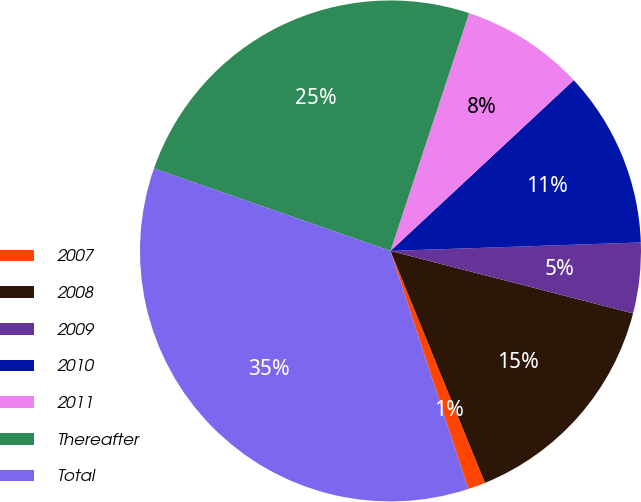<chart> <loc_0><loc_0><loc_500><loc_500><pie_chart><fcel>2007<fcel>2008<fcel>2009<fcel>2010<fcel>2011<fcel>Thereafter<fcel>Total<nl><fcel>1.13%<fcel>14.83%<fcel>4.55%<fcel>11.4%<fcel>7.98%<fcel>24.74%<fcel>35.37%<nl></chart> 